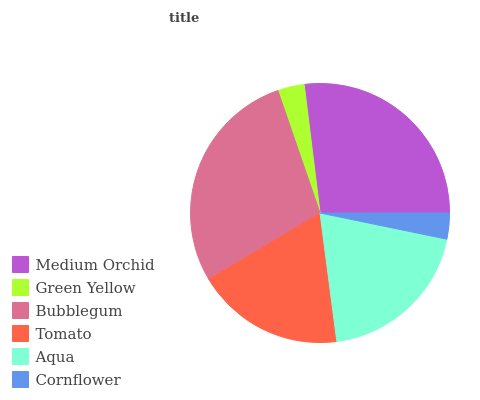Is Cornflower the minimum?
Answer yes or no. Yes. Is Bubblegum the maximum?
Answer yes or no. Yes. Is Green Yellow the minimum?
Answer yes or no. No. Is Green Yellow the maximum?
Answer yes or no. No. Is Medium Orchid greater than Green Yellow?
Answer yes or no. Yes. Is Green Yellow less than Medium Orchid?
Answer yes or no. Yes. Is Green Yellow greater than Medium Orchid?
Answer yes or no. No. Is Medium Orchid less than Green Yellow?
Answer yes or no. No. Is Aqua the high median?
Answer yes or no. Yes. Is Tomato the low median?
Answer yes or no. Yes. Is Green Yellow the high median?
Answer yes or no. No. Is Medium Orchid the low median?
Answer yes or no. No. 